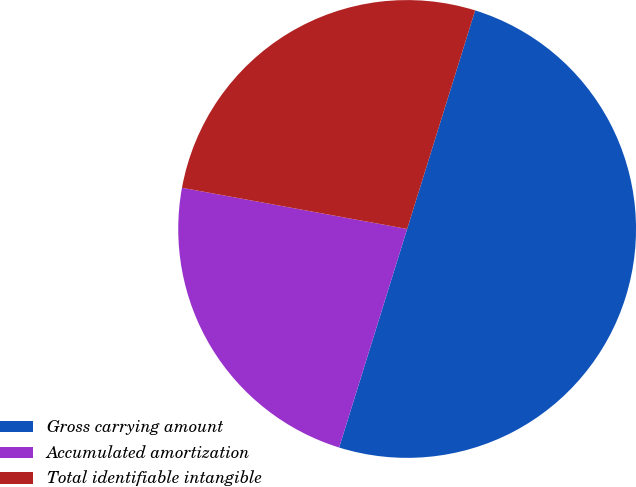Convert chart. <chart><loc_0><loc_0><loc_500><loc_500><pie_chart><fcel>Gross carrying amount<fcel>Accumulated amortization<fcel>Total identifiable intangible<nl><fcel>50.0%<fcel>23.08%<fcel>26.92%<nl></chart> 